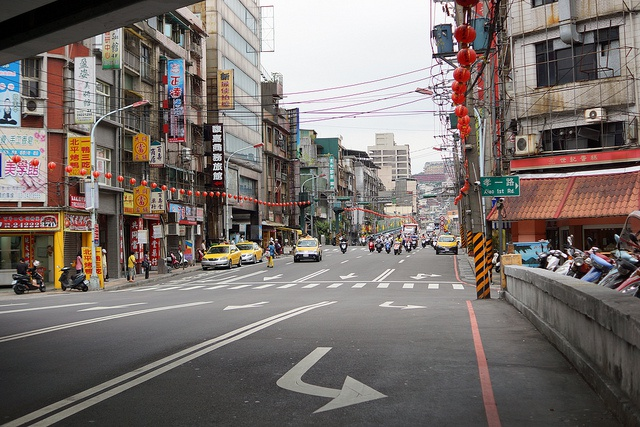Describe the objects in this image and their specific colors. I can see motorcycle in black, gray, maroon, and darkgray tones, car in black, gray, darkgray, and lightgray tones, motorcycle in black, gray, and darkgray tones, people in black, darkgray, gray, and lightgray tones, and motorcycle in black, gray, and maroon tones in this image. 